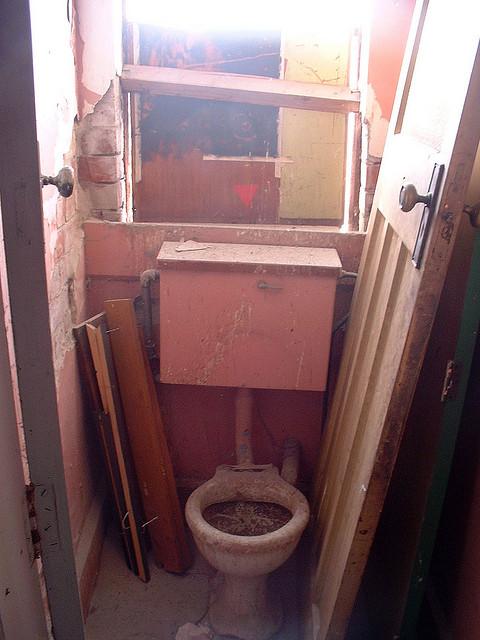Has this bathroom been used recently?
Quick response, please. No. Is the toilet dirty?
Quick response, please. Yes. Is the door functional?
Keep it brief. No. 